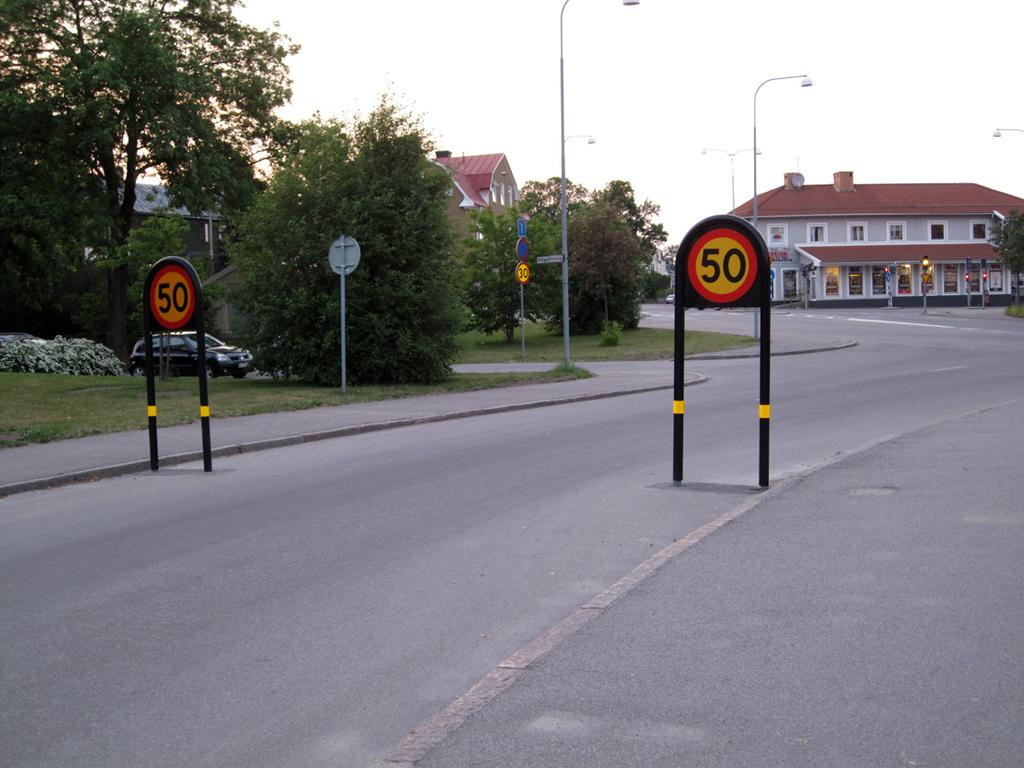<image>
Present a compact description of the photo's key features. Signs that have the number "50" are propped up on the street. 